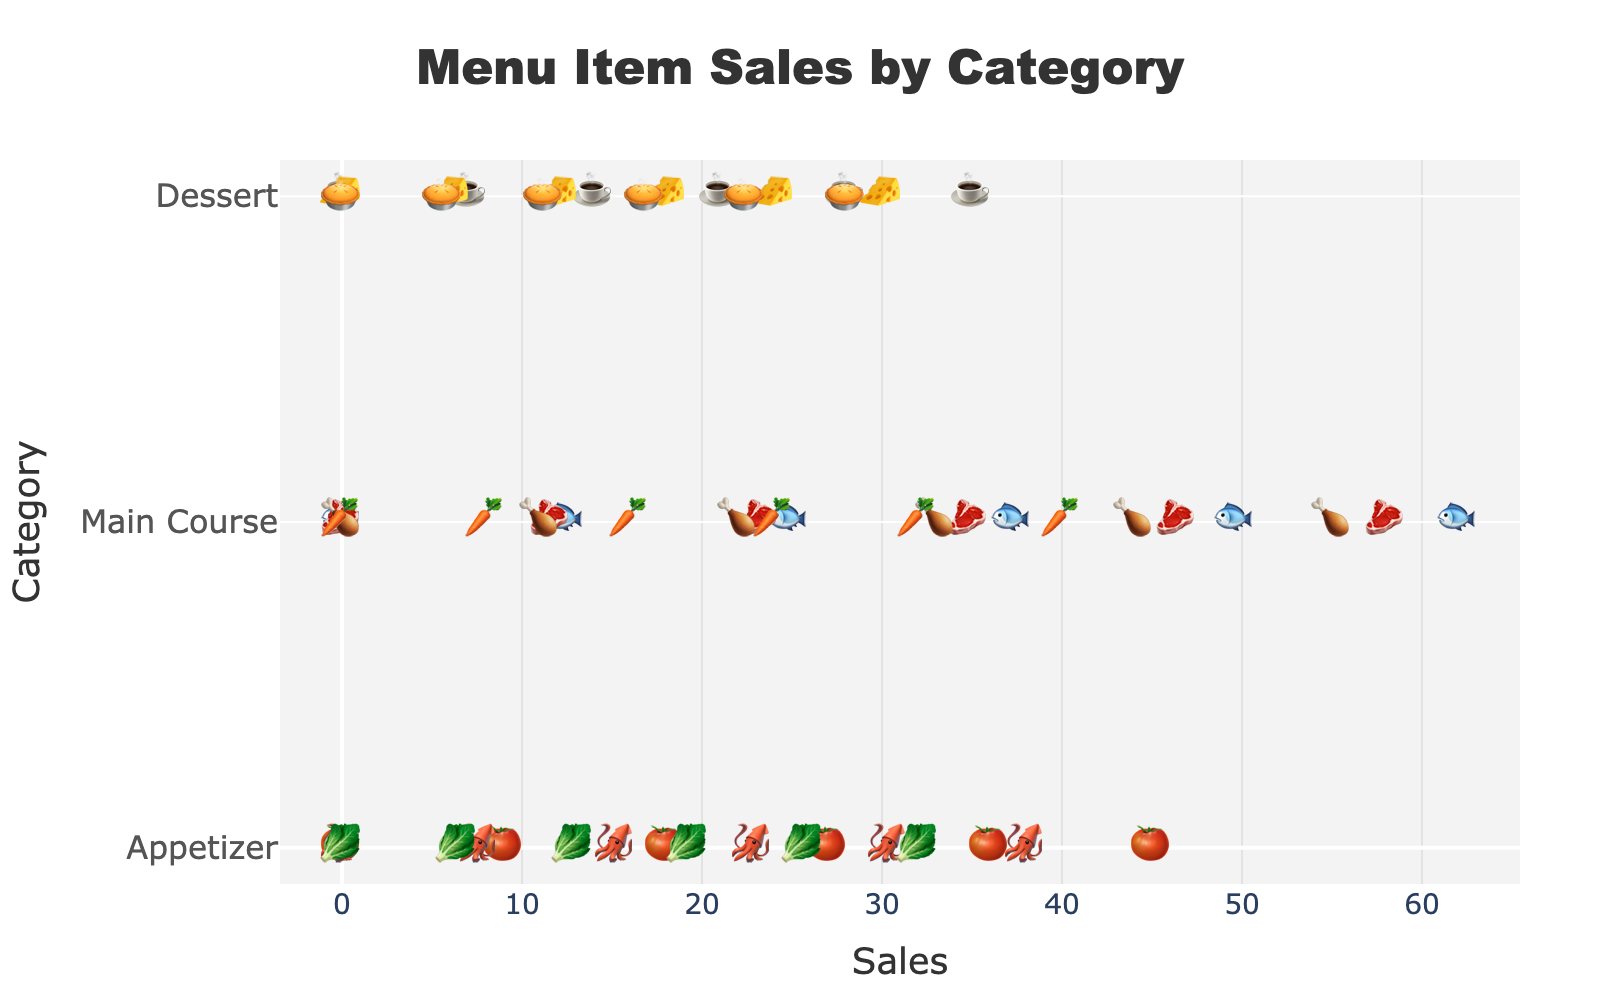What is the title of the plot? The title of the plot is usually located at the top, centered, and often larger in font size compared to other text elements.
Answer: Menu Item Sales by Category Which category has the highest total sales? Sum the sales figures for each category: Appetizer (45 + 38 + 32 = 115), Main Course (62 + 58 + 55 + 40 = 215), Dessert (35 + 30 + 28 = 93). The category with the highest sum is Main Course.
Answer: Main Course How many sales did the best-selling item in the Main Course category achieve? Identify the highest sales number within the Main Course category. The highest sales figure is for Grilled Salmon (62 sales).
Answer: 62 Which item has the fewest sales overall? Compare the sales figures for all items across all categories. The item with the fewest sales is Apple Pie with 28 sales.
Answer: Apple Pie How do the total sales of appetizers compare to the total sales of desserts? Calculate the total sales for each category: Appetizer (45 + 38 + 32 = 115) and Dessert (35 + 30 + 28 = 93). Compare these totals, and see that appetizers have more sales than desserts.
Answer: Appetizers have more sales Arrange the items in the Dessert category by their sales figures. List the Dessert items and their sales, then arrange them in descending order: Tiramisu (35), Cheesecake (30), Apple Pie (28).
Answer: Tiramisu, Cheesecake, Apple Pie What is the average sales for items in the Appetizer category? Calculate the average by summing the sales figures for appetizers and dividing by the number of items: (45 + 38 + 32) / 3 = 115 / 3 = 38.33.
Answer: 38.33 Which item has more sales: Calamari or Vegetable Risotto? Compare the sales figures: Calamari has 38 sales and Vegetable Risotto has 40 sales. Vegetable Risotto has more sales.
Answer: Vegetable Risotto What is the total number of items listed in the plot? Count the items across all categories: Appetizer (3), Main Course (4), Dessert (3). Total: 3 + 4 + 3 = 10.
Answer: 10 What is the median value of sales for the Main Course category? List the sales figures in order: 40, 55, 58, 62. The median is the average of the two middle numbers: (55 + 58) / 2 = 56.5.
Answer: 56.5 